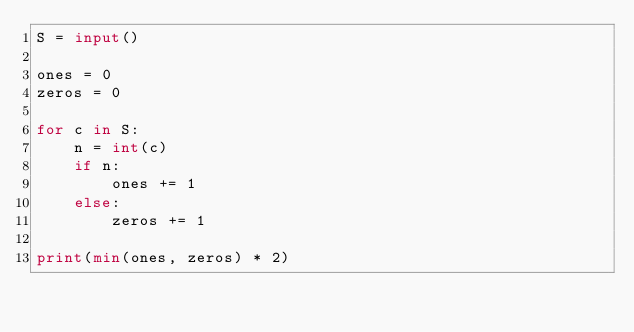Convert code to text. <code><loc_0><loc_0><loc_500><loc_500><_Python_>S = input()

ones = 0
zeros = 0

for c in S:
    n = int(c)
    if n:
        ones += 1
    else:
        zeros += 1

print(min(ones, zeros) * 2)
</code> 